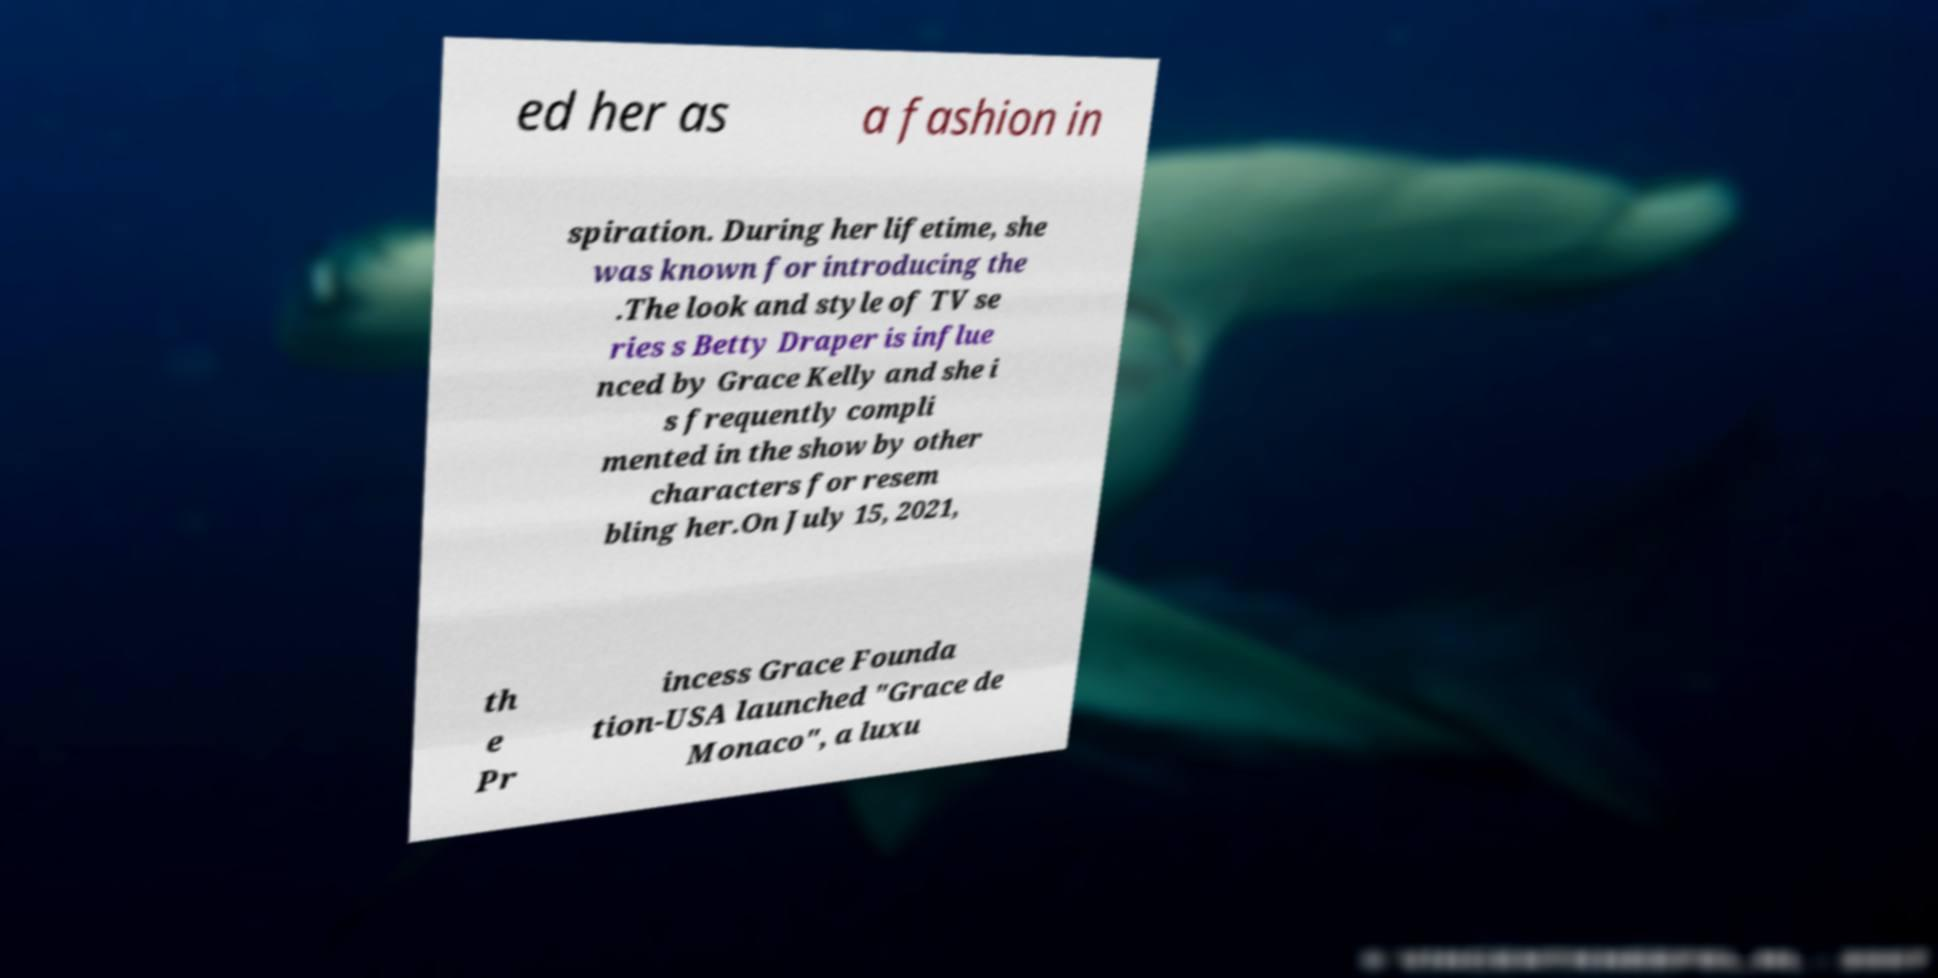Could you extract and type out the text from this image? ed her as a fashion in spiration. During her lifetime, she was known for introducing the .The look and style of TV se ries s Betty Draper is influe nced by Grace Kelly and she i s frequently compli mented in the show by other characters for resem bling her.On July 15, 2021, th e Pr incess Grace Founda tion-USA launched "Grace de Monaco", a luxu 